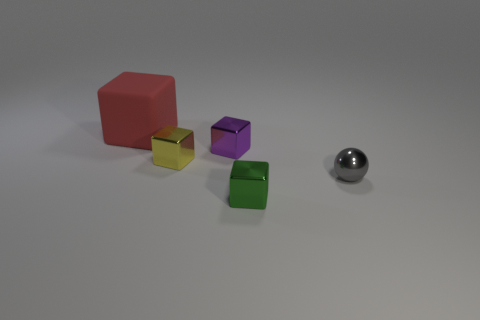Subtract all large red rubber cubes. How many cubes are left? 3 Subtract all red blocks. How many blocks are left? 3 Subtract all balls. How many objects are left? 4 Subtract 1 spheres. How many spheres are left? 0 Add 2 shiny objects. How many objects exist? 7 Add 2 small brown matte things. How many small brown matte things exist? 2 Subtract 0 brown cubes. How many objects are left? 5 Subtract all gray cubes. Subtract all green cylinders. How many cubes are left? 4 Subtract all tiny shiny blocks. Subtract all green rubber blocks. How many objects are left? 2 Add 2 tiny green blocks. How many tiny green blocks are left? 3 